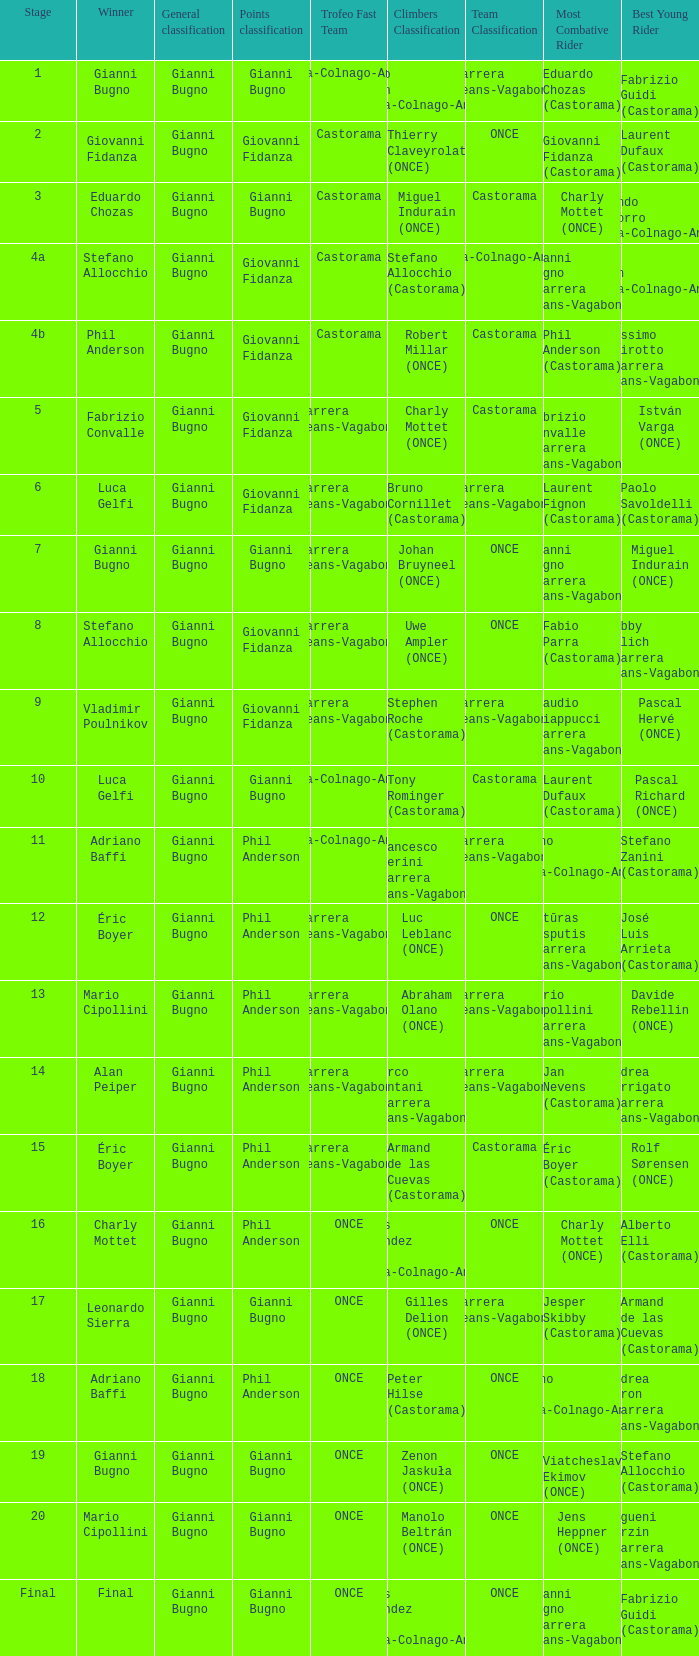Who is the winner when the trofeo fast team is carrera jeans-vagabond in stage 5? Fabrizio Convalle. 